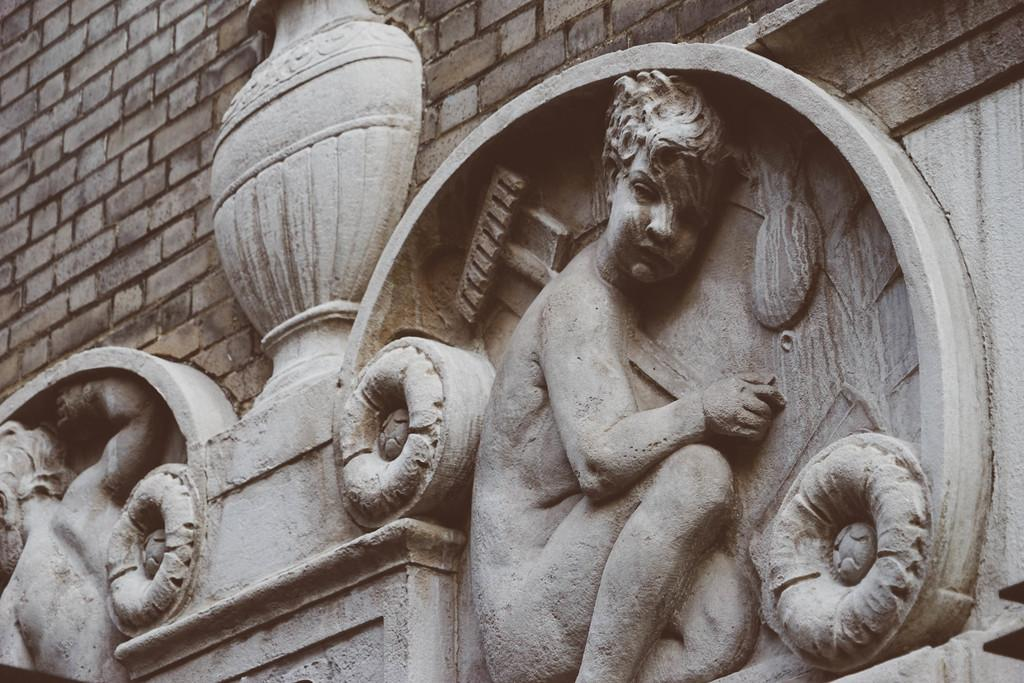What is attached to the wall in the image? There are two depictions attached to the wall in the image. Can you describe the background of the image? There is a wall in the background of the image. How many pizzas are being dropped in the image? There are no pizzas or any indication of dropping in the image. What type of cakes are present in the image? There are no cakes present in the image. 